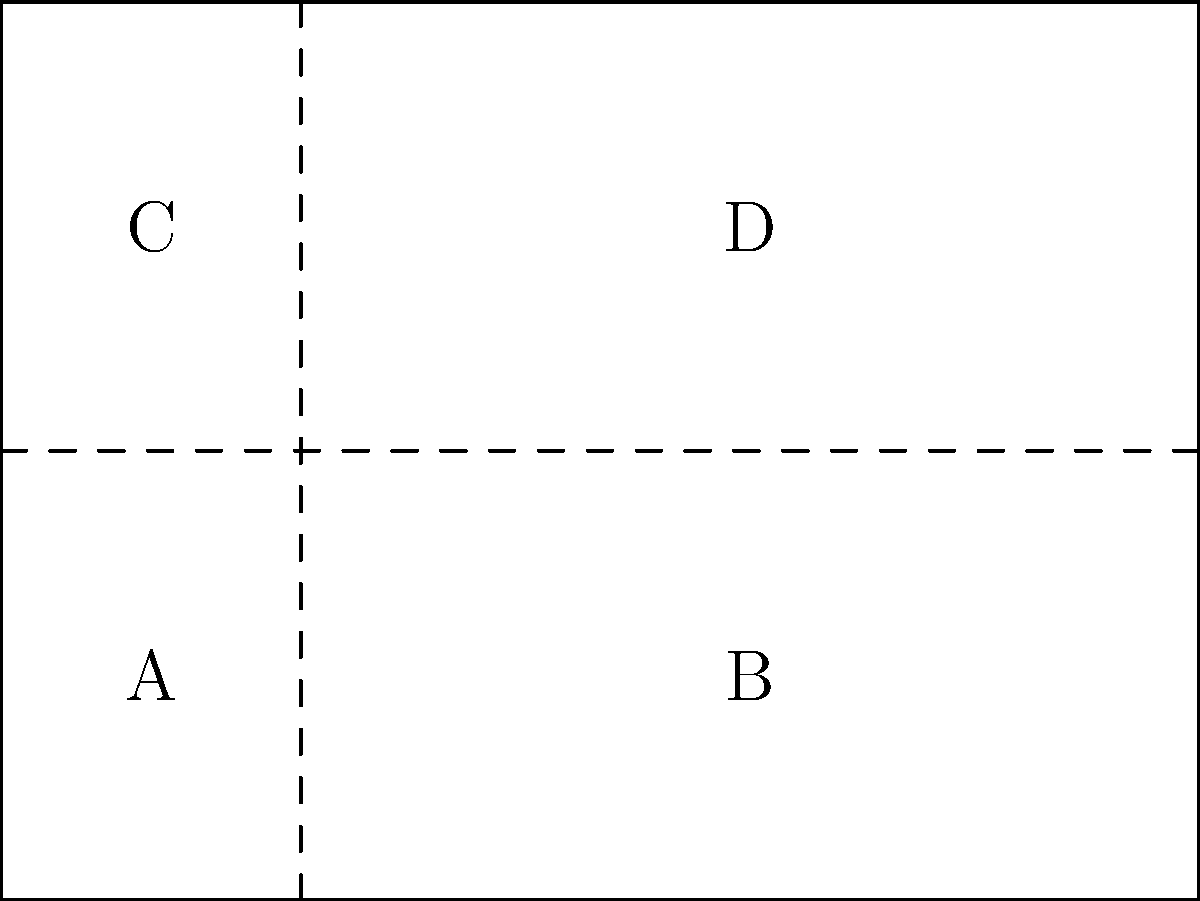A community event flyer is designed to reveal hidden messages when folded. The flyer is divided into four sections labeled A, B, C, and D. If the flyer is first folded along the vertical dashed line and then along the horizontal dashed line, in what order will the sections be revealed when unfolding the flyer? To determine the order in which the sections will be revealed when unfolding the flyer, let's follow the folding and unfolding process step-by-step:

1. Initially, the flyer is folded along the vertical dashed line, bringing section B over section A, and section D over section C.

2. Then, it's folded along the horizontal dashed line, bringing the bottom half (sections A and B) over the top half (sections C and D).

3. When unfolding, we reverse this process:
   a. First, we unfold the horizontal fold, revealing sections C and D.
   b. Then, we unfold the vertical fold, revealing sections A and B.

4. The order of revelation will be:
   - D (top-right) and C (top-left) simultaneously when unfolding horizontally
   - B (bottom-right) and A (bottom-left) simultaneously when unfolding vertically

Therefore, the sections will be revealed in the order: D/C, then B/A.
Answer: D/C, B/A 